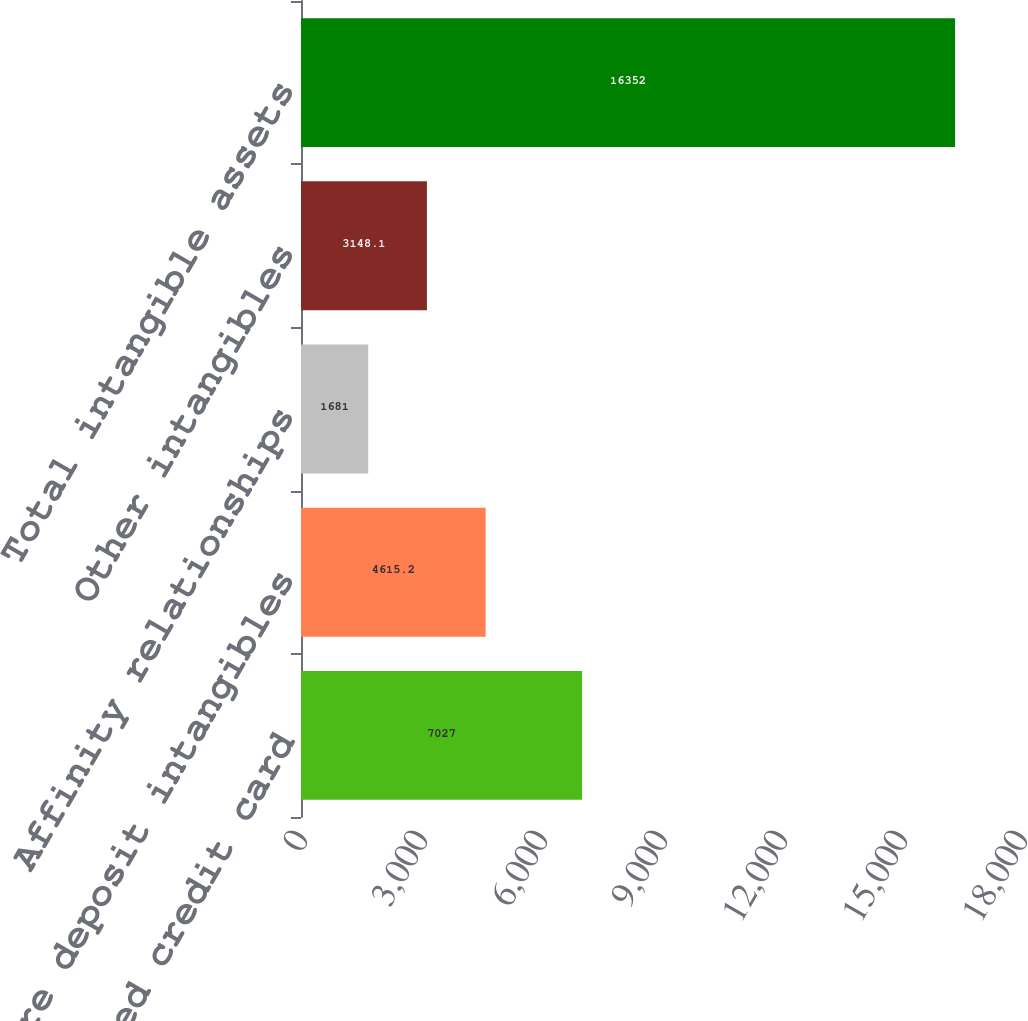Convert chart. <chart><loc_0><loc_0><loc_500><loc_500><bar_chart><fcel>Purchased credit card<fcel>Core deposit intangibles<fcel>Affinity relationships<fcel>Other intangibles<fcel>Total intangible assets<nl><fcel>7027<fcel>4615.2<fcel>1681<fcel>3148.1<fcel>16352<nl></chart> 